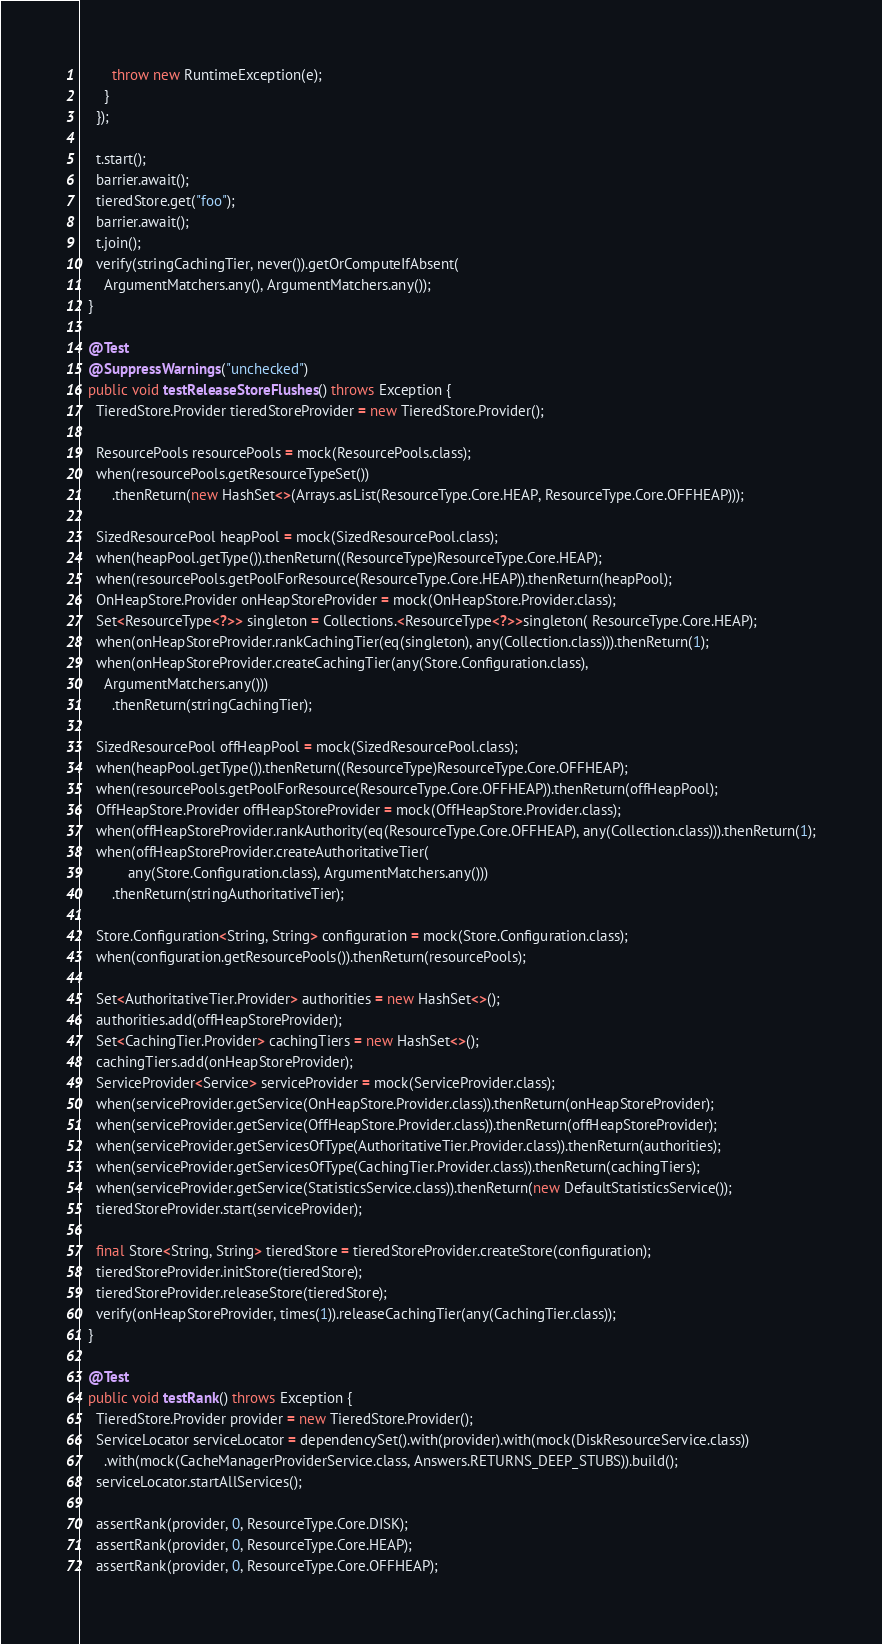Convert code to text. <code><loc_0><loc_0><loc_500><loc_500><_Java_>        throw new RuntimeException(e);
      }
    });

    t.start();
    barrier.await();
    tieredStore.get("foo");
    barrier.await();
    t.join();
    verify(stringCachingTier, never()).getOrComputeIfAbsent(
      ArgumentMatchers.any(), ArgumentMatchers.any());
  }

  @Test
  @SuppressWarnings("unchecked")
  public void testReleaseStoreFlushes() throws Exception {
    TieredStore.Provider tieredStoreProvider = new TieredStore.Provider();

    ResourcePools resourcePools = mock(ResourcePools.class);
    when(resourcePools.getResourceTypeSet())
        .thenReturn(new HashSet<>(Arrays.asList(ResourceType.Core.HEAP, ResourceType.Core.OFFHEAP)));

    SizedResourcePool heapPool = mock(SizedResourcePool.class);
    when(heapPool.getType()).thenReturn((ResourceType)ResourceType.Core.HEAP);
    when(resourcePools.getPoolForResource(ResourceType.Core.HEAP)).thenReturn(heapPool);
    OnHeapStore.Provider onHeapStoreProvider = mock(OnHeapStore.Provider.class);
    Set<ResourceType<?>> singleton = Collections.<ResourceType<?>>singleton( ResourceType.Core.HEAP);
    when(onHeapStoreProvider.rankCachingTier(eq(singleton), any(Collection.class))).thenReturn(1);
    when(onHeapStoreProvider.createCachingTier(any(Store.Configuration.class),
      ArgumentMatchers.any()))
        .thenReturn(stringCachingTier);

    SizedResourcePool offHeapPool = mock(SizedResourcePool.class);
    when(heapPool.getType()).thenReturn((ResourceType)ResourceType.Core.OFFHEAP);
    when(resourcePools.getPoolForResource(ResourceType.Core.OFFHEAP)).thenReturn(offHeapPool);
    OffHeapStore.Provider offHeapStoreProvider = mock(OffHeapStore.Provider.class);
    when(offHeapStoreProvider.rankAuthority(eq(ResourceType.Core.OFFHEAP), any(Collection.class))).thenReturn(1);
    when(offHeapStoreProvider.createAuthoritativeTier(
            any(Store.Configuration.class), ArgumentMatchers.any()))
        .thenReturn(stringAuthoritativeTier);

    Store.Configuration<String, String> configuration = mock(Store.Configuration.class);
    when(configuration.getResourcePools()).thenReturn(resourcePools);

    Set<AuthoritativeTier.Provider> authorities = new HashSet<>();
    authorities.add(offHeapStoreProvider);
    Set<CachingTier.Provider> cachingTiers = new HashSet<>();
    cachingTiers.add(onHeapStoreProvider);
    ServiceProvider<Service> serviceProvider = mock(ServiceProvider.class);
    when(serviceProvider.getService(OnHeapStore.Provider.class)).thenReturn(onHeapStoreProvider);
    when(serviceProvider.getService(OffHeapStore.Provider.class)).thenReturn(offHeapStoreProvider);
    when(serviceProvider.getServicesOfType(AuthoritativeTier.Provider.class)).thenReturn(authorities);
    when(serviceProvider.getServicesOfType(CachingTier.Provider.class)).thenReturn(cachingTiers);
    when(serviceProvider.getService(StatisticsService.class)).thenReturn(new DefaultStatisticsService());
    tieredStoreProvider.start(serviceProvider);

    final Store<String, String> tieredStore = tieredStoreProvider.createStore(configuration);
    tieredStoreProvider.initStore(tieredStore);
    tieredStoreProvider.releaseStore(tieredStore);
    verify(onHeapStoreProvider, times(1)).releaseCachingTier(any(CachingTier.class));
  }

  @Test
  public void testRank() throws Exception {
    TieredStore.Provider provider = new TieredStore.Provider();
    ServiceLocator serviceLocator = dependencySet().with(provider).with(mock(DiskResourceService.class))
      .with(mock(CacheManagerProviderService.class, Answers.RETURNS_DEEP_STUBS)).build();
    serviceLocator.startAllServices();

    assertRank(provider, 0, ResourceType.Core.DISK);
    assertRank(provider, 0, ResourceType.Core.HEAP);
    assertRank(provider, 0, ResourceType.Core.OFFHEAP);</code> 